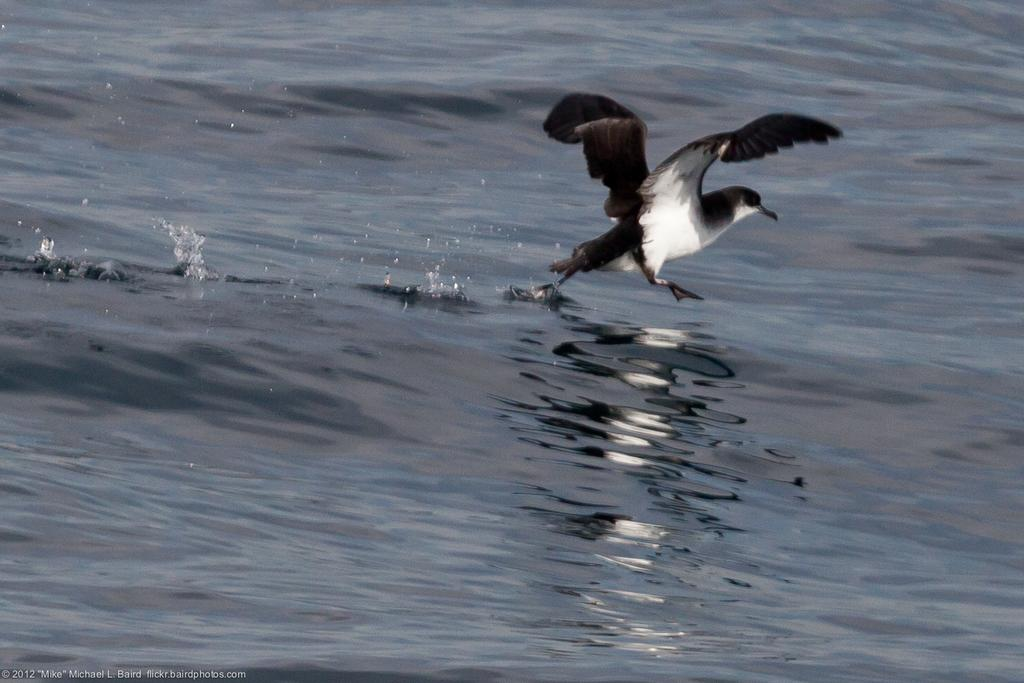What is present in the image that is not solid? There is water visible in the image. What type of animal can be seen in the image? There is a bird in the image. What colors are present on the bird in the image? The bird is white and black in color. What type of mint can be seen growing in the image? There is no mint present in the image; it features water and a bird. 